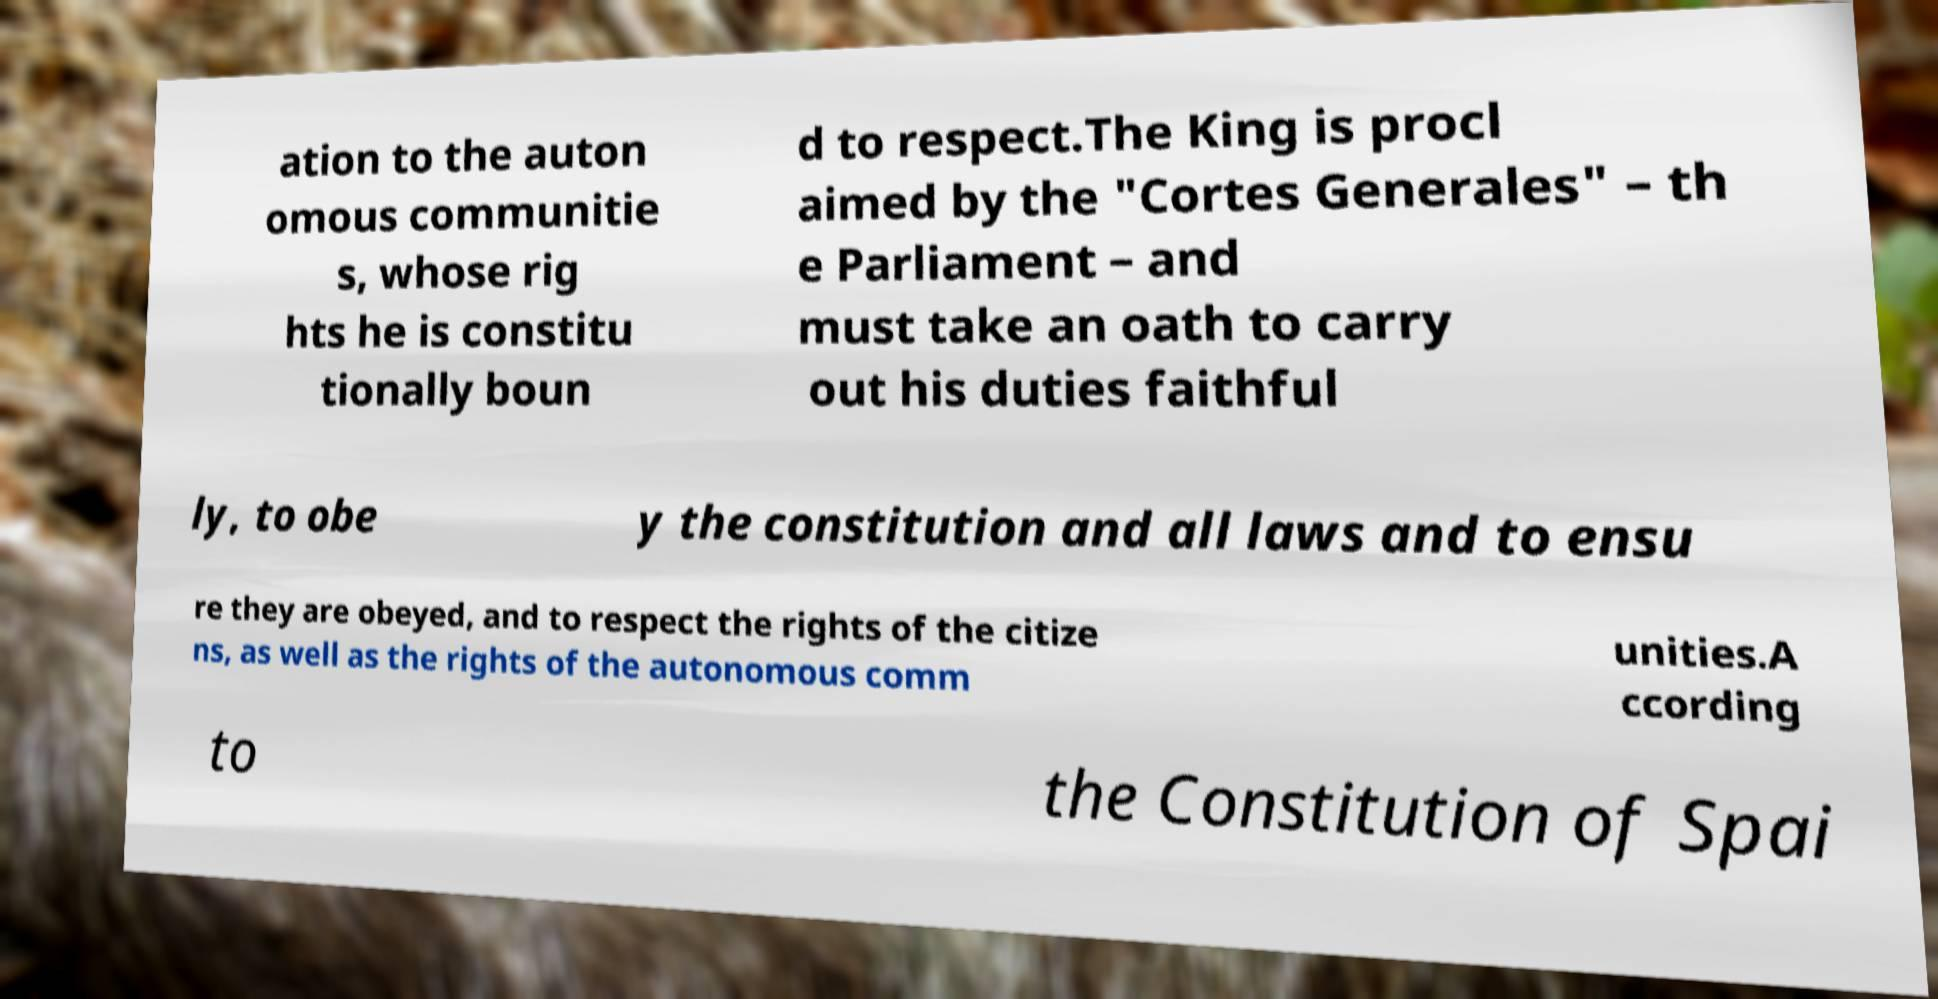I need the written content from this picture converted into text. Can you do that? ation to the auton omous communitie s, whose rig hts he is constitu tionally boun d to respect.The King is procl aimed by the "Cortes Generales" – th e Parliament – and must take an oath to carry out his duties faithful ly, to obe y the constitution and all laws and to ensu re they are obeyed, and to respect the rights of the citize ns, as well as the rights of the autonomous comm unities.A ccording to the Constitution of Spai 